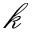Convert formula to latex. <formula><loc_0><loc_0><loc_500><loc_500>\mathcal { k }</formula> 